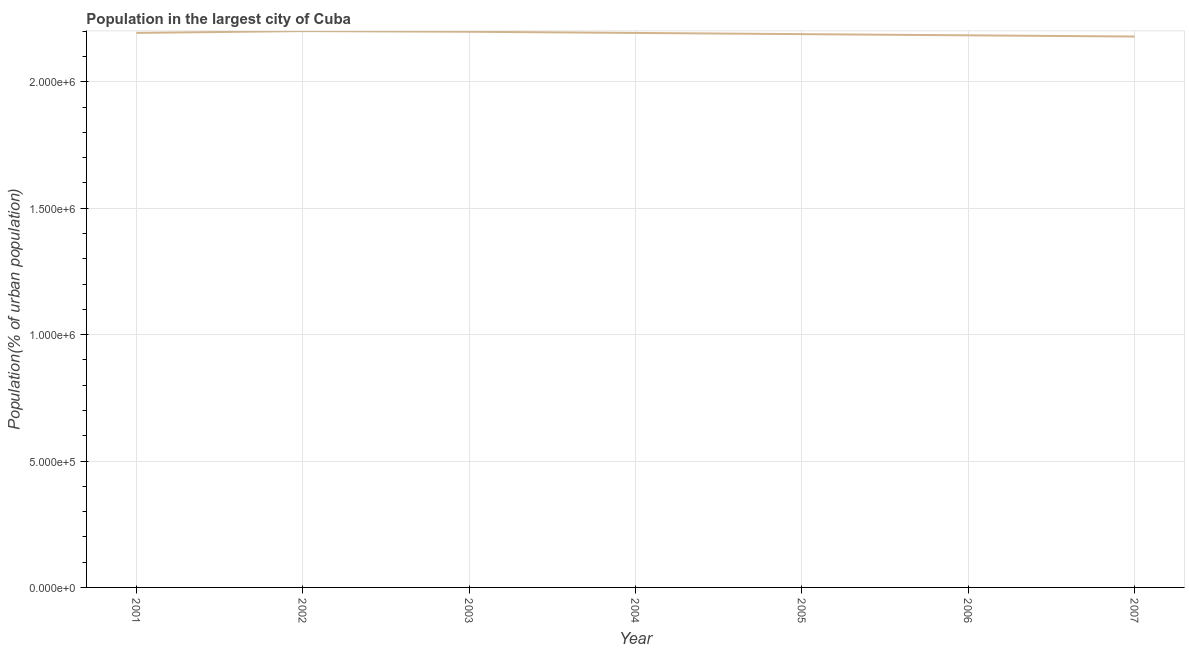What is the population in largest city in 2007?
Make the answer very short. 2.18e+06. Across all years, what is the maximum population in largest city?
Your answer should be compact. 2.20e+06. Across all years, what is the minimum population in largest city?
Make the answer very short. 2.18e+06. In which year was the population in largest city minimum?
Ensure brevity in your answer.  2007. What is the sum of the population in largest city?
Your answer should be compact. 1.53e+07. What is the difference between the population in largest city in 2004 and 2005?
Offer a terse response. 4725. What is the average population in largest city per year?
Your answer should be very brief. 2.19e+06. What is the median population in largest city?
Your answer should be very brief. 2.19e+06. In how many years, is the population in largest city greater than 2000000 %?
Ensure brevity in your answer.  7. What is the ratio of the population in largest city in 2002 to that in 2003?
Provide a short and direct response. 1. Is the population in largest city in 2002 less than that in 2006?
Provide a short and direct response. No. Is the difference between the population in largest city in 2003 and 2005 greater than the difference between any two years?
Offer a very short reply. No. What is the difference between the highest and the second highest population in largest city?
Make the answer very short. 2558. What is the difference between the highest and the lowest population in largest city?
Your answer should be very brief. 2.15e+04. How many lines are there?
Your response must be concise. 1. Does the graph contain any zero values?
Provide a short and direct response. No. What is the title of the graph?
Your answer should be very brief. Population in the largest city of Cuba. What is the label or title of the X-axis?
Ensure brevity in your answer.  Year. What is the label or title of the Y-axis?
Your answer should be very brief. Population(% of urban population). What is the Population(% of urban population) in 2001?
Provide a succinct answer. 2.19e+06. What is the Population(% of urban population) in 2002?
Keep it short and to the point. 2.20e+06. What is the Population(% of urban population) in 2003?
Give a very brief answer. 2.20e+06. What is the Population(% of urban population) in 2004?
Offer a terse response. 2.19e+06. What is the Population(% of urban population) in 2005?
Provide a succinct answer. 2.19e+06. What is the Population(% of urban population) of 2006?
Offer a very short reply. 2.18e+06. What is the Population(% of urban population) of 2007?
Offer a terse response. 2.18e+06. What is the difference between the Population(% of urban population) in 2001 and 2002?
Make the answer very short. -7186. What is the difference between the Population(% of urban population) in 2001 and 2003?
Offer a very short reply. -4628. What is the difference between the Population(% of urban population) in 2001 and 2004?
Provide a succinct answer. 121. What is the difference between the Population(% of urban population) in 2001 and 2005?
Your response must be concise. 4846. What is the difference between the Population(% of urban population) in 2001 and 2006?
Provide a short and direct response. 9568. What is the difference between the Population(% of urban population) in 2001 and 2007?
Offer a terse response. 1.43e+04. What is the difference between the Population(% of urban population) in 2002 and 2003?
Offer a very short reply. 2558. What is the difference between the Population(% of urban population) in 2002 and 2004?
Provide a succinct answer. 7307. What is the difference between the Population(% of urban population) in 2002 and 2005?
Ensure brevity in your answer.  1.20e+04. What is the difference between the Population(% of urban population) in 2002 and 2006?
Give a very brief answer. 1.68e+04. What is the difference between the Population(% of urban population) in 2002 and 2007?
Your answer should be compact. 2.15e+04. What is the difference between the Population(% of urban population) in 2003 and 2004?
Your response must be concise. 4749. What is the difference between the Population(% of urban population) in 2003 and 2005?
Make the answer very short. 9474. What is the difference between the Population(% of urban population) in 2003 and 2006?
Give a very brief answer. 1.42e+04. What is the difference between the Population(% of urban population) in 2003 and 2007?
Make the answer very short. 1.89e+04. What is the difference between the Population(% of urban population) in 2004 and 2005?
Offer a terse response. 4725. What is the difference between the Population(% of urban population) in 2004 and 2006?
Offer a terse response. 9447. What is the difference between the Population(% of urban population) in 2004 and 2007?
Offer a terse response. 1.42e+04. What is the difference between the Population(% of urban population) in 2005 and 2006?
Provide a short and direct response. 4722. What is the difference between the Population(% of urban population) in 2005 and 2007?
Your answer should be compact. 9434. What is the difference between the Population(% of urban population) in 2006 and 2007?
Offer a terse response. 4712. What is the ratio of the Population(% of urban population) in 2001 to that in 2003?
Provide a succinct answer. 1. What is the ratio of the Population(% of urban population) in 2001 to that in 2005?
Make the answer very short. 1. What is the ratio of the Population(% of urban population) in 2001 to that in 2007?
Give a very brief answer. 1.01. What is the ratio of the Population(% of urban population) in 2002 to that in 2004?
Provide a succinct answer. 1. What is the ratio of the Population(% of urban population) in 2002 to that in 2007?
Provide a short and direct response. 1.01. What is the ratio of the Population(% of urban population) in 2003 to that in 2006?
Ensure brevity in your answer.  1.01. What is the ratio of the Population(% of urban population) in 2003 to that in 2007?
Ensure brevity in your answer.  1.01. What is the ratio of the Population(% of urban population) in 2004 to that in 2007?
Offer a very short reply. 1.01. What is the ratio of the Population(% of urban population) in 2005 to that in 2006?
Ensure brevity in your answer.  1. What is the ratio of the Population(% of urban population) in 2006 to that in 2007?
Your answer should be compact. 1. 